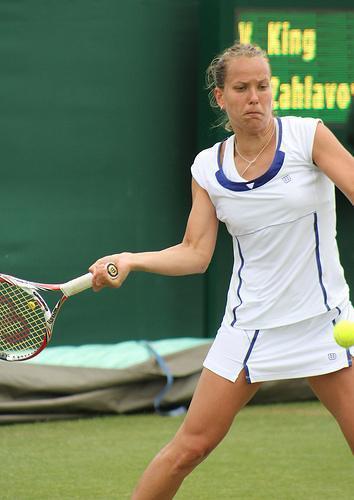How many colors are in the woman's outfit?
Give a very brief answer. 2. 